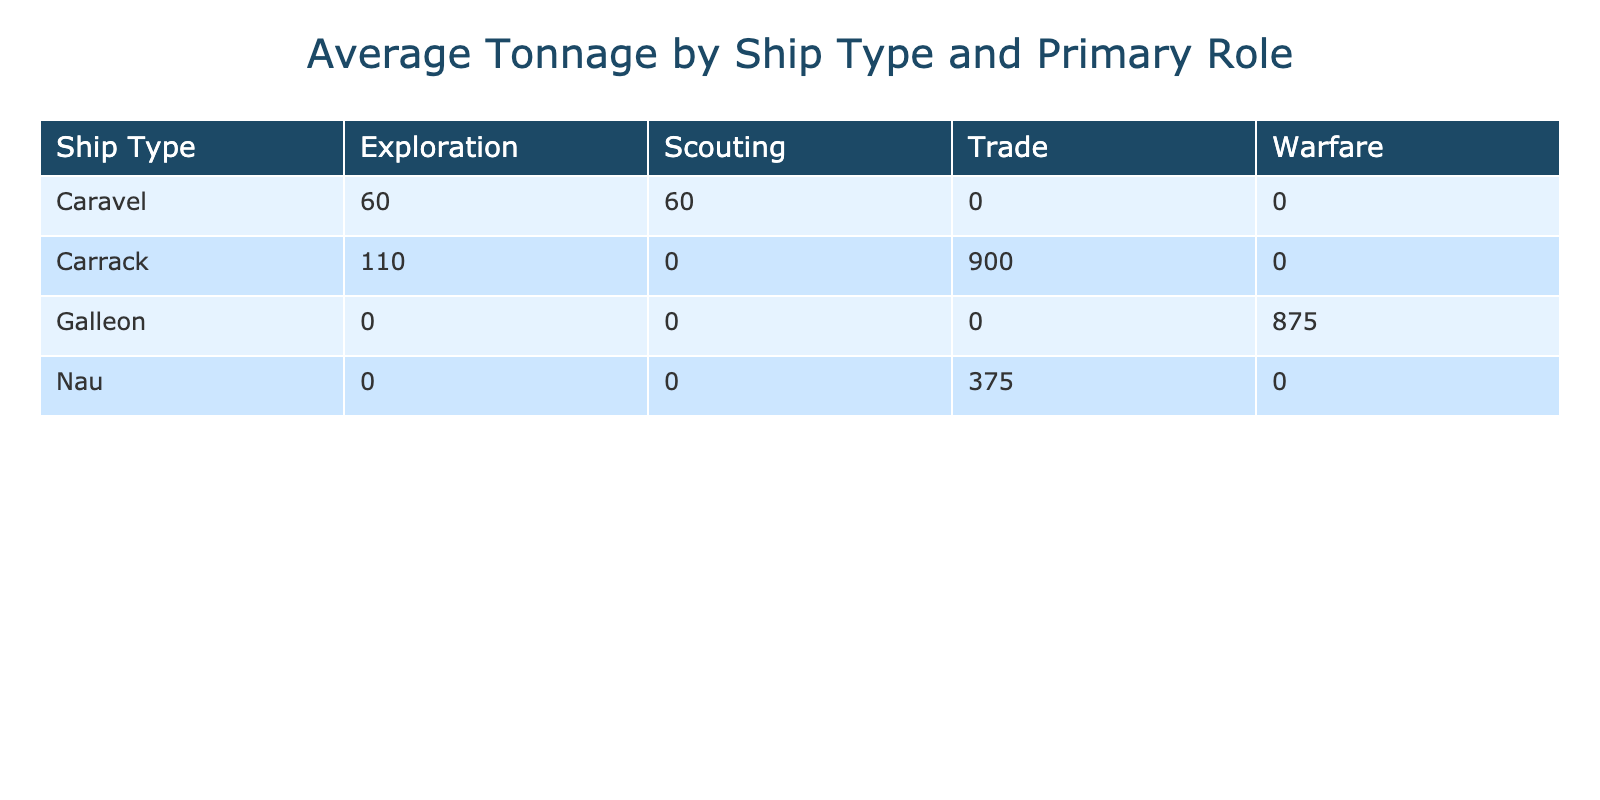What is the average tonnage of Galleons? The average tonnage for Galleons can be calculated by taking the sum of the tonnage values for all Galleons and dividing by the number of Galleons listed. The Galleons listed have tonnage values of 600, 1000, 900, and 1000, resulting in a sum of 3200. There are 4 Galleons, so the average is 3200 divided by 4, which equals 800.
Answer: 800 Which ship type has the highest average tonnage? In the table, the Carrack has an average tonnage of 920, while the Galleon has 800 and the Nau has 350. Based on these averages, the Carrack has the highest average tonnage among the ship types presented.
Answer: Carrack Is there any ship with a primary role of Scouting? Yes, there are two ships classified as Scouting: Berrio and Esmeralda. Both have different tonnage and crew sizes, confirming the presence of ships with this primary role.
Answer: Yes What is the total number of guns on all Carracks combined? To find the total number of guns on all Carracks, we need to sum the number of guns across each Carrack: São Gabriel (20), São Rafael (18), Madre de Deus (70), Cinco Chagas (65), and Frol de la Mar (44). Thus, the total is 20 + 18 + 70 + 65 + 44 = 217.
Answer: 217 How many ships were built before the year 1500? The ships built before 1500 include São Gabriel (1497), São Rafael (1497), Berrio (1495), and Santa Cruz (1490). This counts for a total of 4 ships listed as built before 1500, confirming that there were multiple entries in that timeframe.
Answer: 4 What is the average crew size of the ships with a primary role of Trade? The ships with a primary role of Trade are Anunciada, Flor de la Mar, Madre de Deus, Cinco Chagas, and Frol de la Mar. Their crew sizes are 150, 160, 250, 230, and 155, respectively. First, we sum these sizes: 150 + 160 + 250 + 230 + 155 = 945. Then, we divide by the number of Trade ships (5), giving us an average crew size of 945 divided by 5, which equals 189.
Answer: 189 Does the Home Port Lisbon have the largest number of ships represented in the table? To determine this, we can count the number of ships listed from Lisbon: São Gabriel, São Rafael, Anunciada, Flor de la Mar, São João Baptista, Madre de Deus, and São Pantaleão, which totals 7 ships. Comparing with other ports, Porto has 3 ships and Goa has 1, confirming that Lisbon indeed has the largest representation.
Answer: Yes Which ship type has the least average crew size? The Caravel has an average crew size of 24, while the Nau has 140 and Galleon has 210. The average crew size was lower for the Caravel category as calculated by summing total crew sizes and dividing by the number of Caravels. Hence, the least average crew size can be confirmed as being found in the Caravel type.
Answer: Caravel 